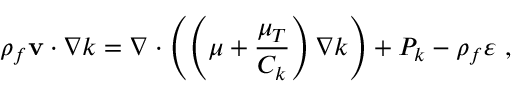<formula> <loc_0><loc_0><loc_500><loc_500>\rho _ { f } { { v } \cdot \nabla } k = \nabla \cdot \left ( \left ( \mu + \frac { \mu _ { T } } { C _ { k } } \right ) \nabla k \right ) + P _ { k } - \rho _ { f } \varepsilon ,</formula> 